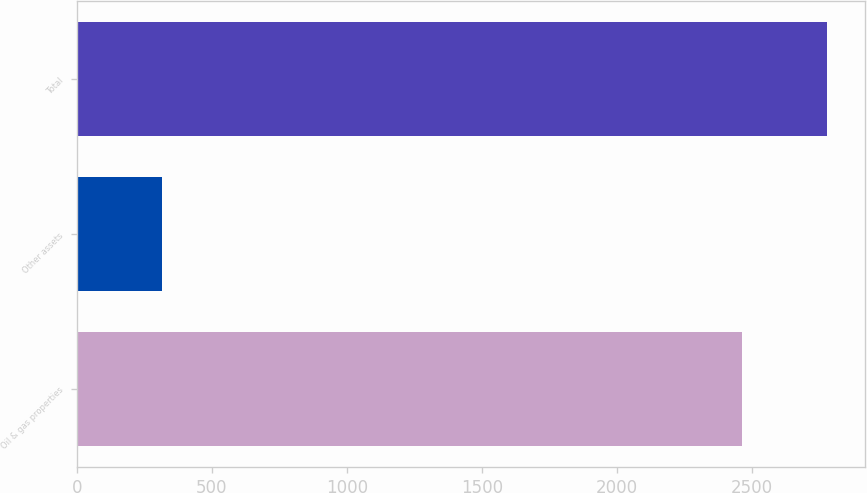<chart> <loc_0><loc_0><loc_500><loc_500><bar_chart><fcel>Oil & gas properties<fcel>Other assets<fcel>Total<nl><fcel>2465<fcel>315<fcel>2780<nl></chart> 